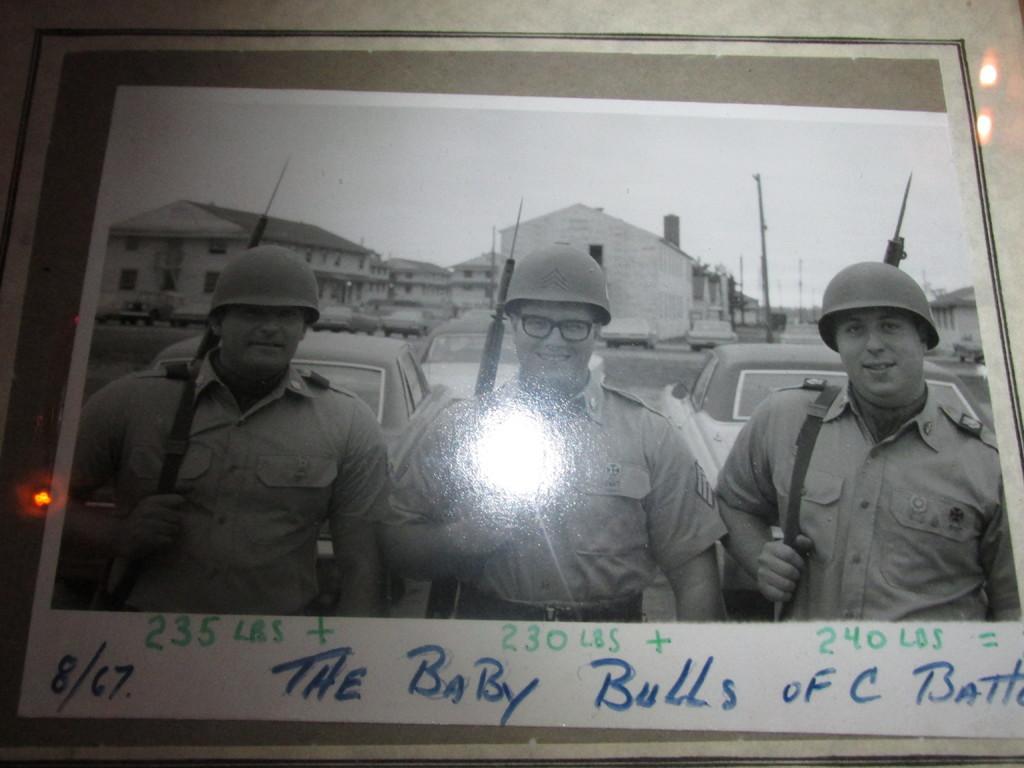In one or two sentences, can you explain what this image depicts? In this image there is a photograph. In the photograph there are three persons standing wearing uniforms, helmets. They are carrying guns. In the background there are cars, buildings. At the bottom few texts are there. 